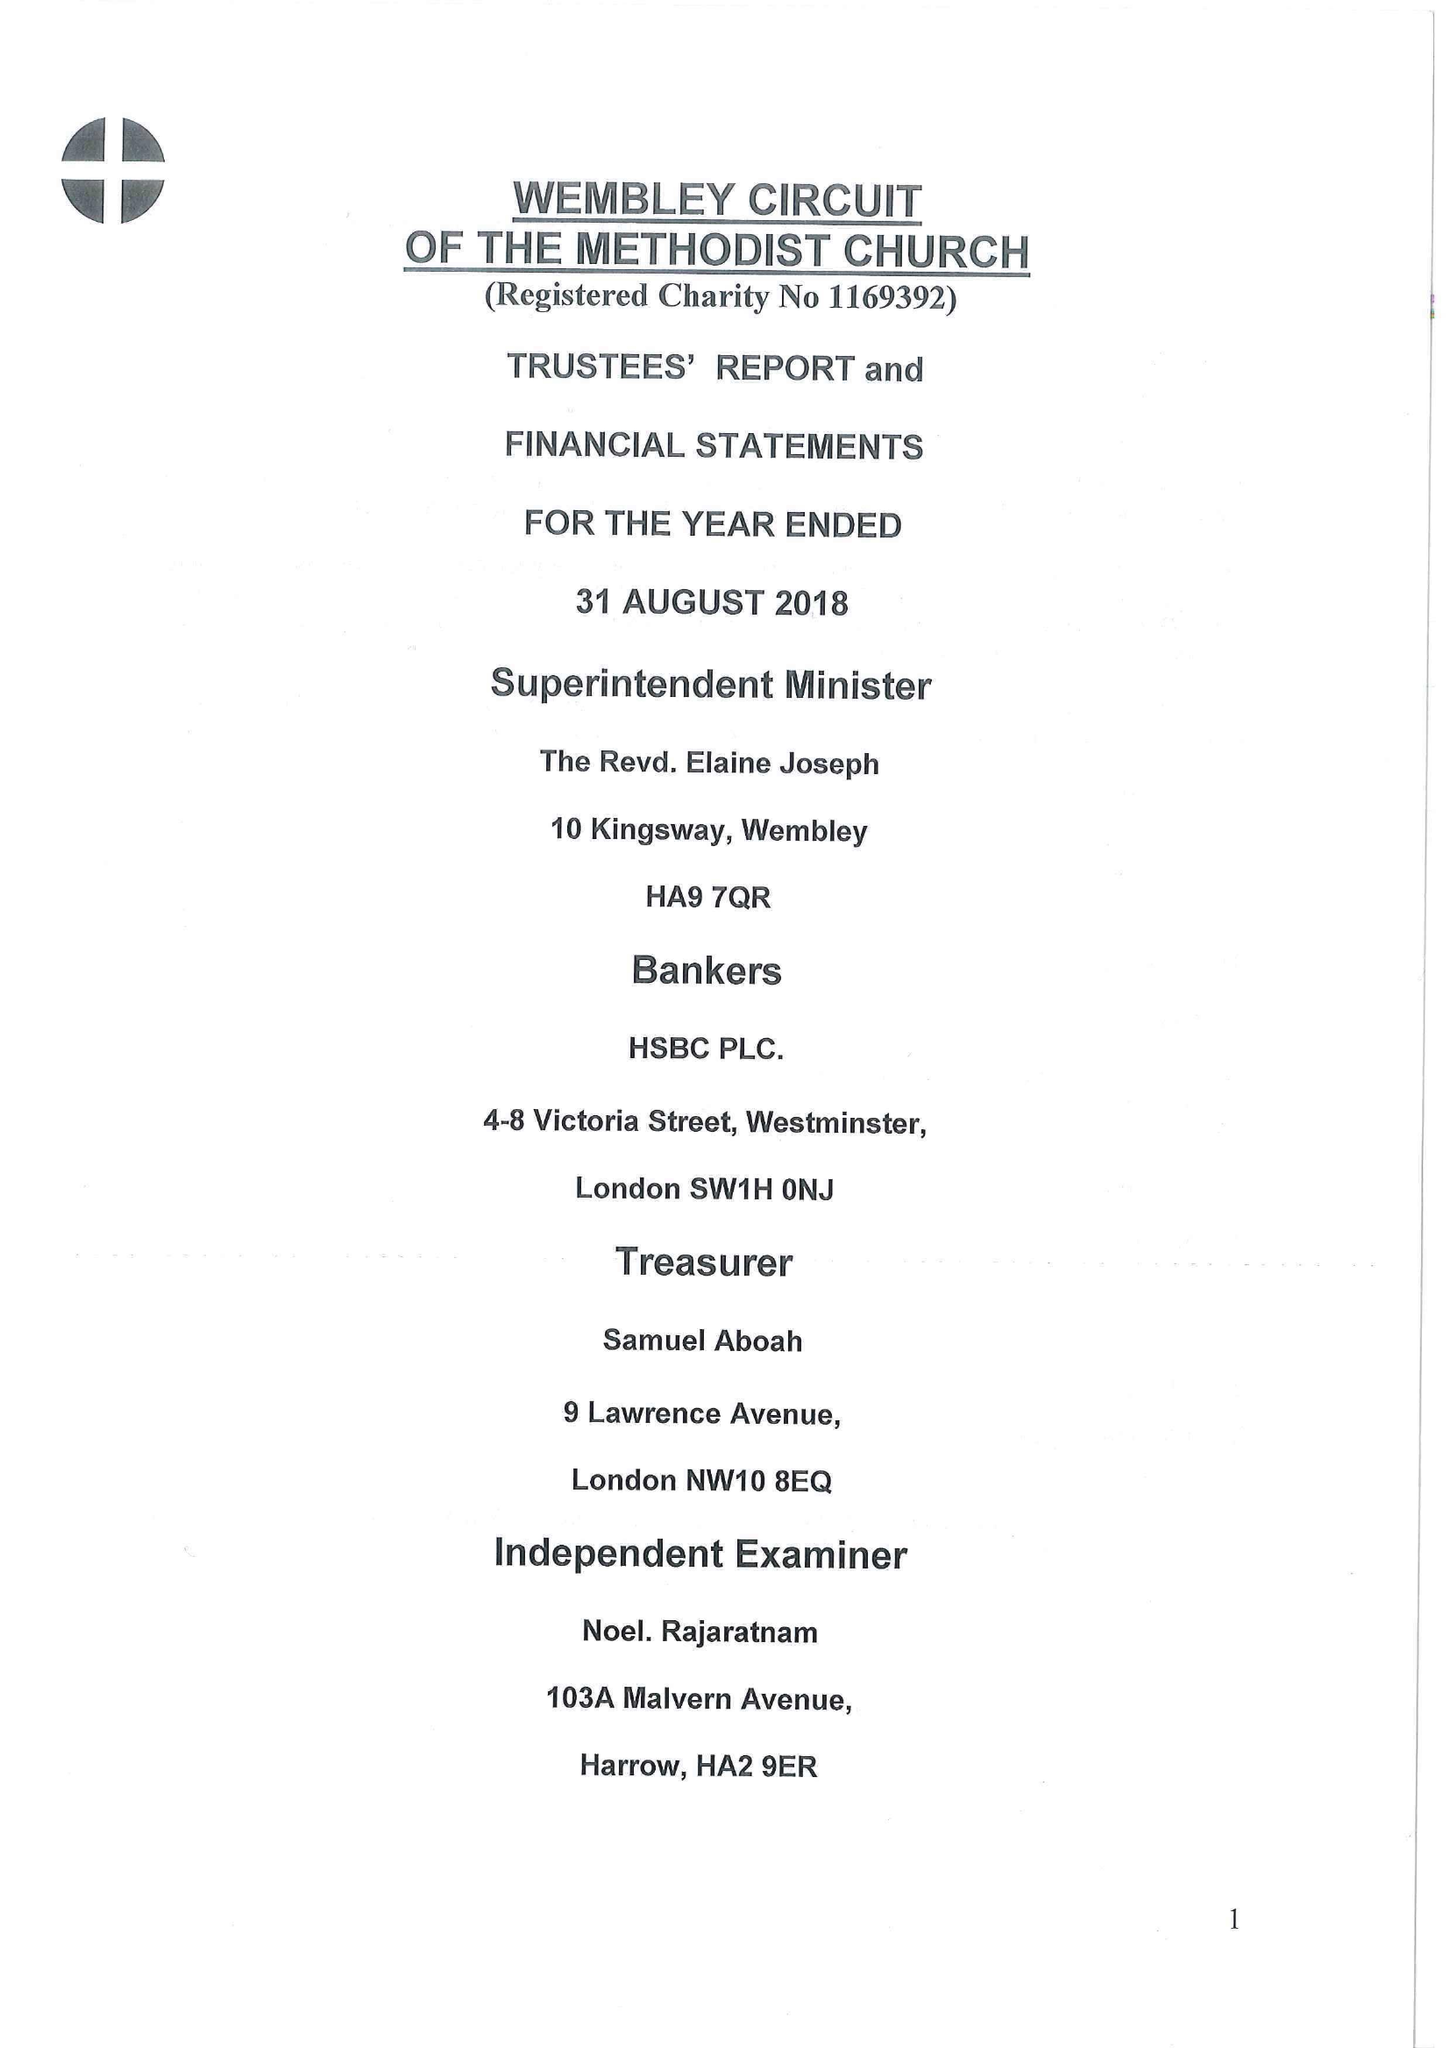What is the value for the spending_annually_in_british_pounds?
Answer the question using a single word or phrase. 158583.00 